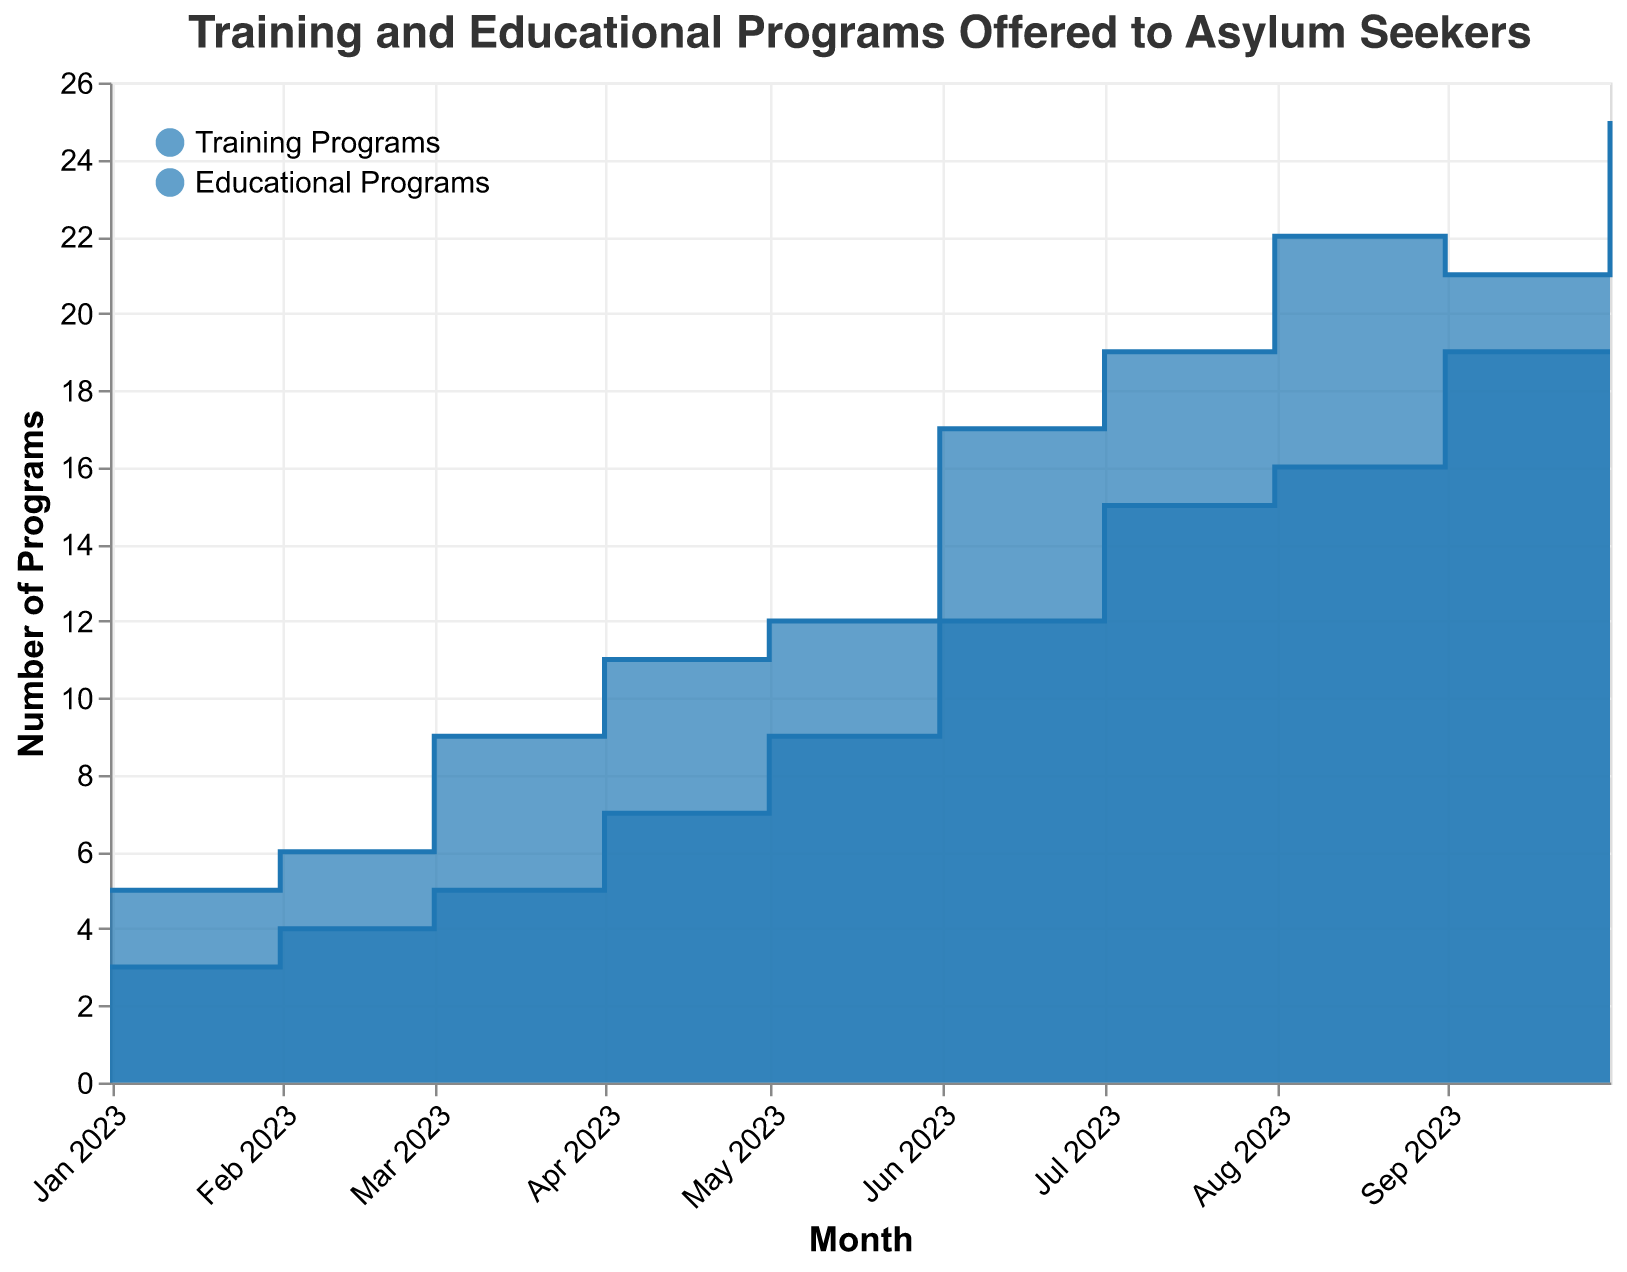What is the title of the chart? The title is usually at the top of the chart and it's a summary of the data being displayed. The provided code shows the title as "Training and Educational Programs Offered to Asylum Seekers".
Answer: Training and Educational Programs Offered to Asylum Seekers Which month had the highest number of total training programs? Scan the "Total Training Programs" area in the chart and look for the highest data point. According to the data for August and September 2023, the numbers are highest.
Answer: October 2023 What is the main difference in the number of programs offered between January 2023 and October 2023? Calculate the total programs in January and October by summing up training and educational programs. For January, T(3+2) + E(1+2) = 3+1+2+2=8. For October, T(8+6+5+6) + E(5+5+5+4) = 8+5+5+6+5+5+5+5=46. The main difference is 46-8.
Answer: 38 How many organizations were offering programs in June 2023? Look at the data for June 2023 and count the unique organizations, Madres de la Esperanza, Proyecto Migrante, Fundación Bienestar, and Educando Sin Fronteras, totaling 4.
Answer: 4 Compare the trend of educational programs between March and September 2023. What do you notice? Educational Programs: March (4+3+1)=8 to September (7+5+5+5)=22. The number of educational programs gradually increases over time.
Answer: The number of programs increases By how much did the total training programs offered by Madres de la Esperanza increase from January to October 2023? Training programs in January: 3. Training programs in October: 8. The increase is 8 - 3 = 5.
Answer: 5 Which organization offered the most educational programs in October 2023? Compare the educational programs data for October across all organizations: Madres de la Esperanza (5), Proyecto Migrante (5), Fundación Bienestar (5), Educando Sin Fronteras (4). Highest value is 5, an equal value for three organizations.
Answer: Madres de la Esperanza, Proyecto Migrante, Fundación Bienestar What is the average number of educational programs offered in May 2023? Sum the educational programs in May (3+3+3)=9, count the number of organizations (3), and divide the total by count: 9/3 = 3.
Answer: 3 For which month is there the smallest difference between the number of training and educational programs? Compare differences for each month. Smallest difference: April (11 training - 7 educational) = 4. No smaller difference identified in other months.
Answer: April 2023 How does the number of total training programs change from June to July 2023? Compare June total training (6+4+4+3)=17 and July (6+5+4+4)=19. The change is 19-17 = +2.
Answer: Increased by 2 